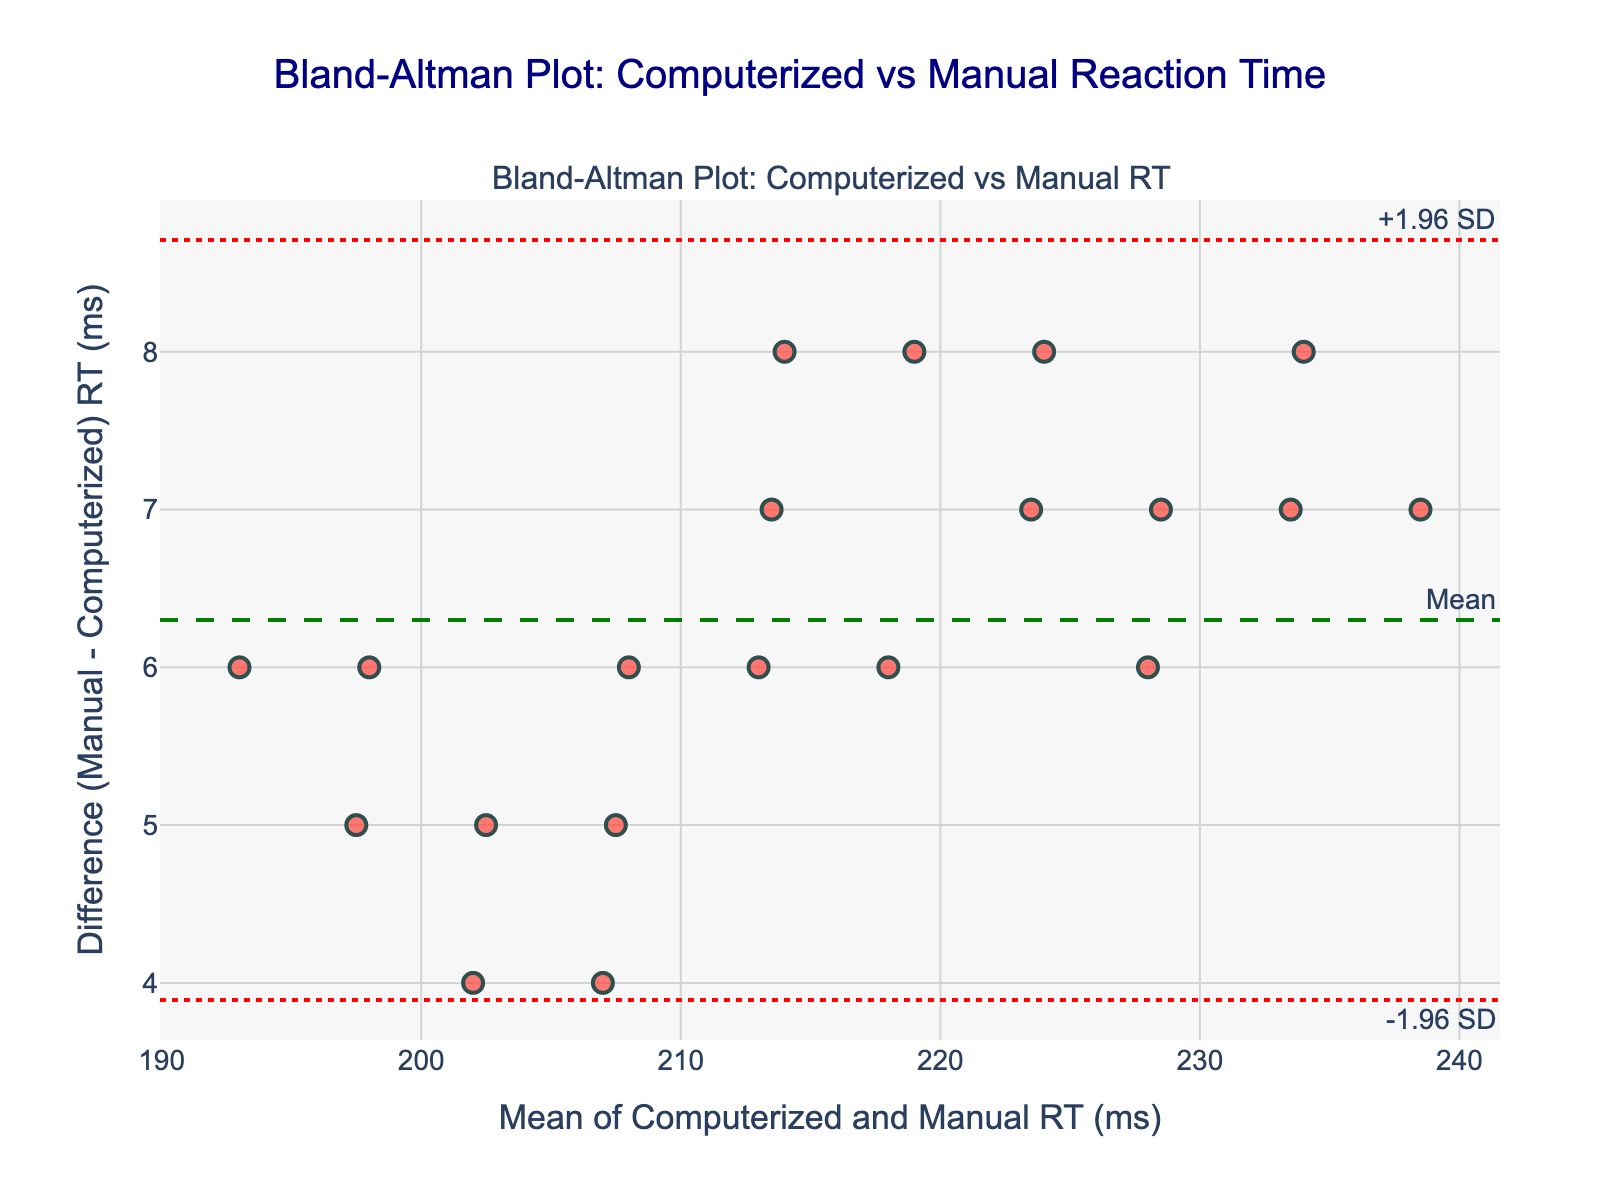What is the title of the plot? The title of the plot is shown at the top of the figure. It reads "Bland-Altman Plot: Computerized vs Manual Reaction Time".
Answer: Bland-Altman Plot: Computerized vs Manual Reaction Time What are the x-axis and y-axis labels in the plot? The x-axis and y-axis labels are located at the bottom and left side of the plot respectively. The x-axis label is "Mean of Computerized and Manual RT (ms)" and the y-axis label is "Difference (Manual - Computerized) RT (ms)".
Answer: Mean of Computerized and Manual RT (ms) and Difference (Manual - Computerized) RT (ms) How many data points are there in the plot? The number of data points can be determined by counting the markers on the plot. Each marker represents an athlete's reaction time measurements.
Answer: 20 What is the mean difference between computerized and manual reaction times? The mean difference between the two methods is indicated by the dashed horizontal green line labeled "Mean". This line represents the average difference (Manual - Computerized) RT.
Answer: 5 ms What are the limits of agreement in the plot? The limits of agreement can be identified by the red dotted lines labeled "+1.96 SD" and "-1.96 SD". These lines indicate the upper and lower bounds of the differences.
Answer: Approximately +10.78 ms and -0.78 ms How many data points fall within the limits of agreement? To determine the number of data points within the limits of agreement, count the markers that lie between the upper and lower red dotted lines. Most data points should fall within these limits if the methods are in good agreement.
Answer: 18 For which athlete is the difference between reaction times the greatest? The difference can be identified by finding the point that lies furthest from the mean difference line. This point corresponds to the athlete with the most significant discrepancy between computerized and manual reaction times.
Answer: Emma Gonzalez What does the spread of the data points suggest about the consistency between computerized and manual measurements? The spread of data points relative to the mean difference line indicates how consistent the two measurement methods are. If most points are close to the mean line and within the limits of agreement, it suggests good consistency.
Answer: Good consistency Is there any bias observed between the computerized and manual measurements? Bias can be detected by observing how many points lie consistently on one side of the mean difference line. If many points lie above or below, it indicates a systematic bias.
Answer: Slight positive bias Which method appears to have generally faster reaction times, computerized or manual? Since the y-axis represents Manual RT minus Computerized RT and the mean difference line is above zero, this suggests that manual measurement times are generally higher (slower) than computerized times.
Answer: Computerized 